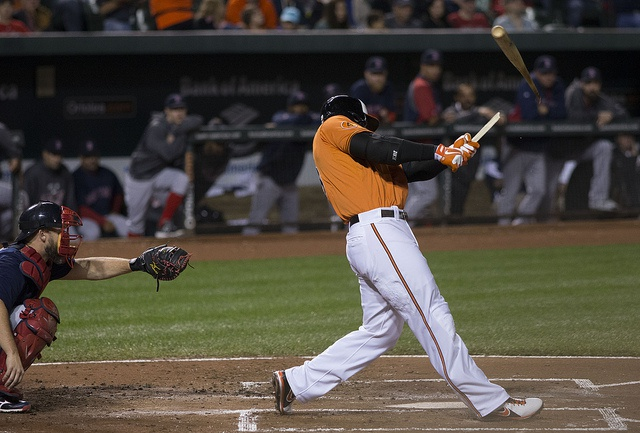Describe the objects in this image and their specific colors. I can see people in black, lavender, darkgray, and orange tones, people in black, maroon, and gray tones, people in black, gray, and maroon tones, people in black and gray tones, and people in black and gray tones in this image. 